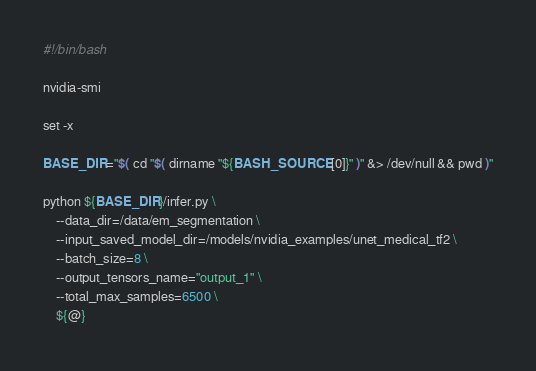<code> <loc_0><loc_0><loc_500><loc_500><_Bash_>#!/bin/bash

nvidia-smi

set -x

BASE_DIR="$( cd "$( dirname "${BASH_SOURCE[0]}" )" &> /dev/null && pwd )"

python ${BASE_DIR}/infer.py \
    --data_dir=/data/em_segmentation \
    --input_saved_model_dir=/models/nvidia_examples/unet_medical_tf2 \
    --batch_size=8 \
    --output_tensors_name="output_1" \
    --total_max_samples=6500 \
    ${@}</code> 